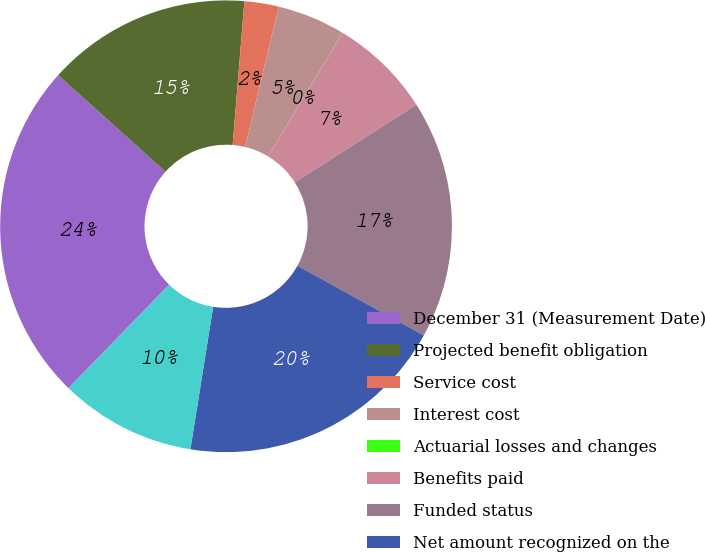Convert chart. <chart><loc_0><loc_0><loc_500><loc_500><pie_chart><fcel>December 31 (Measurement Date)<fcel>Projected benefit obligation<fcel>Service cost<fcel>Interest cost<fcel>Actuarial losses and changes<fcel>Benefits paid<fcel>Funded status<fcel>Net amount recognized on the<fcel>Net actuarial loss<nl><fcel>24.38%<fcel>14.63%<fcel>2.45%<fcel>4.88%<fcel>0.01%<fcel>7.32%<fcel>17.07%<fcel>19.5%<fcel>9.76%<nl></chart> 